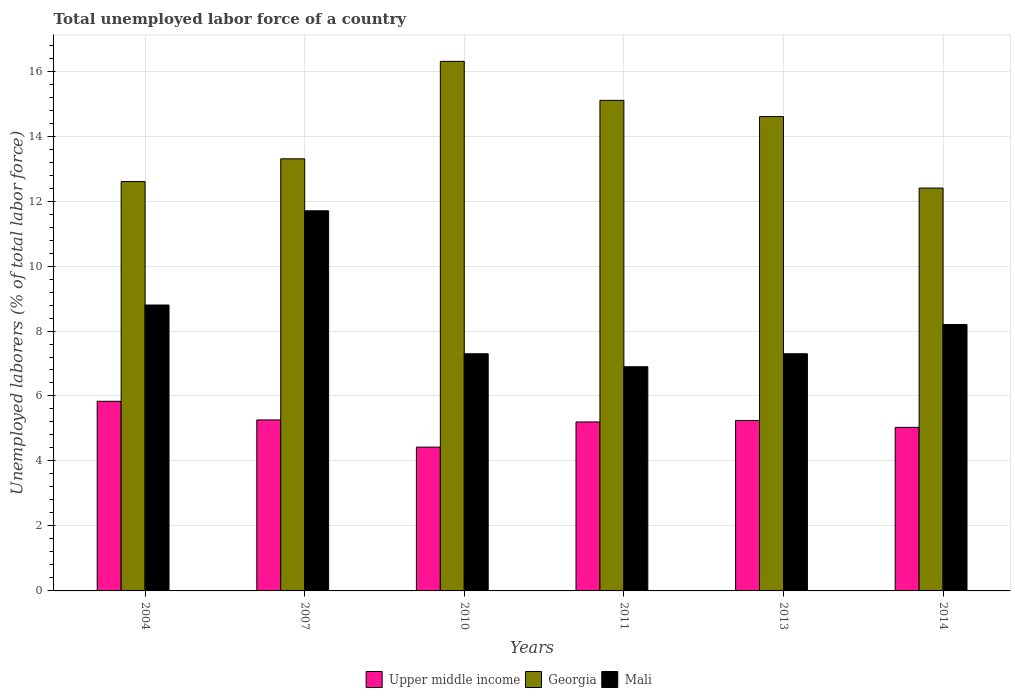Are the number of bars per tick equal to the number of legend labels?
Provide a short and direct response. Yes. How many bars are there on the 4th tick from the left?
Give a very brief answer. 3. What is the label of the 3rd group of bars from the left?
Your response must be concise. 2010. In how many cases, is the number of bars for a given year not equal to the number of legend labels?
Your answer should be compact. 0. What is the total unemployed labor force in Georgia in 2010?
Keep it short and to the point. 16.3. Across all years, what is the maximum total unemployed labor force in Upper middle income?
Your response must be concise. 5.84. Across all years, what is the minimum total unemployed labor force in Mali?
Provide a succinct answer. 6.9. What is the total total unemployed labor force in Upper middle income in the graph?
Your response must be concise. 31.01. What is the difference between the total unemployed labor force in Mali in 2007 and that in 2011?
Keep it short and to the point. 4.8. What is the difference between the total unemployed labor force in Mali in 2011 and the total unemployed labor force in Georgia in 2014?
Give a very brief answer. -5.5. What is the average total unemployed labor force in Georgia per year?
Offer a terse response. 14.05. In the year 2013, what is the difference between the total unemployed labor force in Upper middle income and total unemployed labor force in Mali?
Ensure brevity in your answer.  -2.05. In how many years, is the total unemployed labor force in Mali greater than 8 %?
Keep it short and to the point. 3. What is the ratio of the total unemployed labor force in Georgia in 2004 to that in 2011?
Make the answer very short. 0.83. Is the total unemployed labor force in Georgia in 2007 less than that in 2013?
Offer a terse response. Yes. What is the difference between the highest and the second highest total unemployed labor force in Upper middle income?
Your response must be concise. 0.57. What is the difference between the highest and the lowest total unemployed labor force in Mali?
Make the answer very short. 4.8. In how many years, is the total unemployed labor force in Georgia greater than the average total unemployed labor force in Georgia taken over all years?
Provide a succinct answer. 3. Is the sum of the total unemployed labor force in Upper middle income in 2004 and 2007 greater than the maximum total unemployed labor force in Mali across all years?
Your answer should be very brief. No. What does the 3rd bar from the left in 2004 represents?
Provide a succinct answer. Mali. What does the 3rd bar from the right in 2007 represents?
Offer a terse response. Upper middle income. Are all the bars in the graph horizontal?
Offer a very short reply. No. How many years are there in the graph?
Your response must be concise. 6. What is the difference between two consecutive major ticks on the Y-axis?
Offer a very short reply. 2. Where does the legend appear in the graph?
Ensure brevity in your answer.  Bottom center. How many legend labels are there?
Ensure brevity in your answer.  3. What is the title of the graph?
Provide a succinct answer. Total unemployed labor force of a country. What is the label or title of the X-axis?
Provide a short and direct response. Years. What is the label or title of the Y-axis?
Make the answer very short. Unemployed laborers (% of total labor force). What is the Unemployed laborers (% of total labor force) in Upper middle income in 2004?
Offer a very short reply. 5.84. What is the Unemployed laborers (% of total labor force) of Georgia in 2004?
Provide a short and direct response. 12.6. What is the Unemployed laborers (% of total labor force) of Mali in 2004?
Offer a terse response. 8.8. What is the Unemployed laborers (% of total labor force) of Upper middle income in 2007?
Make the answer very short. 5.26. What is the Unemployed laborers (% of total labor force) in Georgia in 2007?
Your answer should be compact. 13.3. What is the Unemployed laborers (% of total labor force) in Mali in 2007?
Ensure brevity in your answer.  11.7. What is the Unemployed laborers (% of total labor force) in Upper middle income in 2010?
Provide a short and direct response. 4.43. What is the Unemployed laborers (% of total labor force) of Georgia in 2010?
Your answer should be very brief. 16.3. What is the Unemployed laborers (% of total labor force) of Mali in 2010?
Your answer should be compact. 7.3. What is the Unemployed laborers (% of total labor force) in Upper middle income in 2011?
Your response must be concise. 5.2. What is the Unemployed laborers (% of total labor force) of Georgia in 2011?
Your answer should be compact. 15.1. What is the Unemployed laborers (% of total labor force) of Mali in 2011?
Give a very brief answer. 6.9. What is the Unemployed laborers (% of total labor force) in Upper middle income in 2013?
Give a very brief answer. 5.25. What is the Unemployed laborers (% of total labor force) of Georgia in 2013?
Provide a short and direct response. 14.6. What is the Unemployed laborers (% of total labor force) in Mali in 2013?
Your response must be concise. 7.3. What is the Unemployed laborers (% of total labor force) of Upper middle income in 2014?
Your response must be concise. 5.03. What is the Unemployed laborers (% of total labor force) in Georgia in 2014?
Give a very brief answer. 12.4. What is the Unemployed laborers (% of total labor force) in Mali in 2014?
Ensure brevity in your answer.  8.2. Across all years, what is the maximum Unemployed laborers (% of total labor force) in Upper middle income?
Offer a very short reply. 5.84. Across all years, what is the maximum Unemployed laborers (% of total labor force) of Georgia?
Provide a short and direct response. 16.3. Across all years, what is the maximum Unemployed laborers (% of total labor force) of Mali?
Keep it short and to the point. 11.7. Across all years, what is the minimum Unemployed laborers (% of total labor force) of Upper middle income?
Provide a succinct answer. 4.43. Across all years, what is the minimum Unemployed laborers (% of total labor force) in Georgia?
Offer a very short reply. 12.4. Across all years, what is the minimum Unemployed laborers (% of total labor force) in Mali?
Keep it short and to the point. 6.9. What is the total Unemployed laborers (% of total labor force) in Upper middle income in the graph?
Ensure brevity in your answer.  31.01. What is the total Unemployed laborers (% of total labor force) of Georgia in the graph?
Your answer should be compact. 84.3. What is the total Unemployed laborers (% of total labor force) of Mali in the graph?
Your answer should be compact. 50.2. What is the difference between the Unemployed laborers (% of total labor force) of Upper middle income in 2004 and that in 2007?
Offer a very short reply. 0.57. What is the difference between the Unemployed laborers (% of total labor force) in Georgia in 2004 and that in 2007?
Provide a succinct answer. -0.7. What is the difference between the Unemployed laborers (% of total labor force) of Mali in 2004 and that in 2007?
Offer a very short reply. -2.9. What is the difference between the Unemployed laborers (% of total labor force) of Upper middle income in 2004 and that in 2010?
Give a very brief answer. 1.41. What is the difference between the Unemployed laborers (% of total labor force) of Georgia in 2004 and that in 2010?
Your response must be concise. -3.7. What is the difference between the Unemployed laborers (% of total labor force) of Mali in 2004 and that in 2010?
Offer a terse response. 1.5. What is the difference between the Unemployed laborers (% of total labor force) of Upper middle income in 2004 and that in 2011?
Your response must be concise. 0.64. What is the difference between the Unemployed laborers (% of total labor force) of Upper middle income in 2004 and that in 2013?
Keep it short and to the point. 0.59. What is the difference between the Unemployed laborers (% of total labor force) of Georgia in 2004 and that in 2013?
Ensure brevity in your answer.  -2. What is the difference between the Unemployed laborers (% of total labor force) in Mali in 2004 and that in 2013?
Your response must be concise. 1.5. What is the difference between the Unemployed laborers (% of total labor force) of Upper middle income in 2004 and that in 2014?
Provide a short and direct response. 0.8. What is the difference between the Unemployed laborers (% of total labor force) of Mali in 2004 and that in 2014?
Your answer should be very brief. 0.6. What is the difference between the Unemployed laborers (% of total labor force) in Upper middle income in 2007 and that in 2010?
Ensure brevity in your answer.  0.84. What is the difference between the Unemployed laborers (% of total labor force) in Mali in 2007 and that in 2010?
Give a very brief answer. 4.4. What is the difference between the Unemployed laborers (% of total labor force) in Upper middle income in 2007 and that in 2011?
Your answer should be compact. 0.06. What is the difference between the Unemployed laborers (% of total labor force) in Georgia in 2007 and that in 2011?
Your response must be concise. -1.8. What is the difference between the Unemployed laborers (% of total labor force) of Upper middle income in 2007 and that in 2013?
Provide a succinct answer. 0.02. What is the difference between the Unemployed laborers (% of total labor force) in Upper middle income in 2007 and that in 2014?
Make the answer very short. 0.23. What is the difference between the Unemployed laborers (% of total labor force) in Mali in 2007 and that in 2014?
Ensure brevity in your answer.  3.5. What is the difference between the Unemployed laborers (% of total labor force) of Upper middle income in 2010 and that in 2011?
Your response must be concise. -0.77. What is the difference between the Unemployed laborers (% of total labor force) of Georgia in 2010 and that in 2011?
Offer a very short reply. 1.2. What is the difference between the Unemployed laborers (% of total labor force) of Mali in 2010 and that in 2011?
Give a very brief answer. 0.4. What is the difference between the Unemployed laborers (% of total labor force) of Upper middle income in 2010 and that in 2013?
Ensure brevity in your answer.  -0.82. What is the difference between the Unemployed laborers (% of total labor force) of Georgia in 2010 and that in 2013?
Offer a very short reply. 1.7. What is the difference between the Unemployed laborers (% of total labor force) of Mali in 2010 and that in 2013?
Give a very brief answer. 0. What is the difference between the Unemployed laborers (% of total labor force) of Upper middle income in 2010 and that in 2014?
Offer a terse response. -0.61. What is the difference between the Unemployed laborers (% of total labor force) of Upper middle income in 2011 and that in 2013?
Offer a terse response. -0.05. What is the difference between the Unemployed laborers (% of total labor force) of Georgia in 2011 and that in 2013?
Your answer should be compact. 0.5. What is the difference between the Unemployed laborers (% of total labor force) in Upper middle income in 2011 and that in 2014?
Your response must be concise. 0.17. What is the difference between the Unemployed laborers (% of total labor force) in Georgia in 2011 and that in 2014?
Give a very brief answer. 2.7. What is the difference between the Unemployed laborers (% of total labor force) of Mali in 2011 and that in 2014?
Provide a short and direct response. -1.3. What is the difference between the Unemployed laborers (% of total labor force) of Upper middle income in 2013 and that in 2014?
Provide a short and direct response. 0.21. What is the difference between the Unemployed laborers (% of total labor force) in Upper middle income in 2004 and the Unemployed laborers (% of total labor force) in Georgia in 2007?
Make the answer very short. -7.46. What is the difference between the Unemployed laborers (% of total labor force) of Upper middle income in 2004 and the Unemployed laborers (% of total labor force) of Mali in 2007?
Keep it short and to the point. -5.86. What is the difference between the Unemployed laborers (% of total labor force) in Upper middle income in 2004 and the Unemployed laborers (% of total labor force) in Georgia in 2010?
Provide a short and direct response. -10.46. What is the difference between the Unemployed laborers (% of total labor force) of Upper middle income in 2004 and the Unemployed laborers (% of total labor force) of Mali in 2010?
Ensure brevity in your answer.  -1.46. What is the difference between the Unemployed laborers (% of total labor force) of Georgia in 2004 and the Unemployed laborers (% of total labor force) of Mali in 2010?
Provide a succinct answer. 5.3. What is the difference between the Unemployed laborers (% of total labor force) in Upper middle income in 2004 and the Unemployed laborers (% of total labor force) in Georgia in 2011?
Your response must be concise. -9.26. What is the difference between the Unemployed laborers (% of total labor force) in Upper middle income in 2004 and the Unemployed laborers (% of total labor force) in Mali in 2011?
Your answer should be compact. -1.06. What is the difference between the Unemployed laborers (% of total labor force) in Upper middle income in 2004 and the Unemployed laborers (% of total labor force) in Georgia in 2013?
Offer a very short reply. -8.76. What is the difference between the Unemployed laborers (% of total labor force) in Upper middle income in 2004 and the Unemployed laborers (% of total labor force) in Mali in 2013?
Give a very brief answer. -1.46. What is the difference between the Unemployed laborers (% of total labor force) in Upper middle income in 2004 and the Unemployed laborers (% of total labor force) in Georgia in 2014?
Your response must be concise. -6.56. What is the difference between the Unemployed laborers (% of total labor force) in Upper middle income in 2004 and the Unemployed laborers (% of total labor force) in Mali in 2014?
Offer a very short reply. -2.36. What is the difference between the Unemployed laborers (% of total labor force) in Upper middle income in 2007 and the Unemployed laborers (% of total labor force) in Georgia in 2010?
Your response must be concise. -11.04. What is the difference between the Unemployed laborers (% of total labor force) in Upper middle income in 2007 and the Unemployed laborers (% of total labor force) in Mali in 2010?
Your answer should be compact. -2.04. What is the difference between the Unemployed laborers (% of total labor force) of Georgia in 2007 and the Unemployed laborers (% of total labor force) of Mali in 2010?
Provide a succinct answer. 6. What is the difference between the Unemployed laborers (% of total labor force) in Upper middle income in 2007 and the Unemployed laborers (% of total labor force) in Georgia in 2011?
Make the answer very short. -9.84. What is the difference between the Unemployed laborers (% of total labor force) in Upper middle income in 2007 and the Unemployed laborers (% of total labor force) in Mali in 2011?
Your answer should be very brief. -1.64. What is the difference between the Unemployed laborers (% of total labor force) in Upper middle income in 2007 and the Unemployed laborers (% of total labor force) in Georgia in 2013?
Make the answer very short. -9.34. What is the difference between the Unemployed laborers (% of total labor force) in Upper middle income in 2007 and the Unemployed laborers (% of total labor force) in Mali in 2013?
Your response must be concise. -2.04. What is the difference between the Unemployed laborers (% of total labor force) of Georgia in 2007 and the Unemployed laborers (% of total labor force) of Mali in 2013?
Provide a short and direct response. 6. What is the difference between the Unemployed laborers (% of total labor force) of Upper middle income in 2007 and the Unemployed laborers (% of total labor force) of Georgia in 2014?
Your response must be concise. -7.14. What is the difference between the Unemployed laborers (% of total labor force) of Upper middle income in 2007 and the Unemployed laborers (% of total labor force) of Mali in 2014?
Give a very brief answer. -2.94. What is the difference between the Unemployed laborers (% of total labor force) in Upper middle income in 2010 and the Unemployed laborers (% of total labor force) in Georgia in 2011?
Keep it short and to the point. -10.67. What is the difference between the Unemployed laborers (% of total labor force) of Upper middle income in 2010 and the Unemployed laborers (% of total labor force) of Mali in 2011?
Give a very brief answer. -2.47. What is the difference between the Unemployed laborers (% of total labor force) of Georgia in 2010 and the Unemployed laborers (% of total labor force) of Mali in 2011?
Offer a terse response. 9.4. What is the difference between the Unemployed laborers (% of total labor force) of Upper middle income in 2010 and the Unemployed laborers (% of total labor force) of Georgia in 2013?
Make the answer very short. -10.17. What is the difference between the Unemployed laborers (% of total labor force) of Upper middle income in 2010 and the Unemployed laborers (% of total labor force) of Mali in 2013?
Give a very brief answer. -2.87. What is the difference between the Unemployed laborers (% of total labor force) in Upper middle income in 2010 and the Unemployed laborers (% of total labor force) in Georgia in 2014?
Your answer should be compact. -7.97. What is the difference between the Unemployed laborers (% of total labor force) of Upper middle income in 2010 and the Unemployed laborers (% of total labor force) of Mali in 2014?
Provide a short and direct response. -3.77. What is the difference between the Unemployed laborers (% of total labor force) of Georgia in 2010 and the Unemployed laborers (% of total labor force) of Mali in 2014?
Provide a succinct answer. 8.1. What is the difference between the Unemployed laborers (% of total labor force) of Upper middle income in 2011 and the Unemployed laborers (% of total labor force) of Georgia in 2013?
Provide a short and direct response. -9.4. What is the difference between the Unemployed laborers (% of total labor force) of Upper middle income in 2011 and the Unemployed laborers (% of total labor force) of Mali in 2013?
Keep it short and to the point. -2.1. What is the difference between the Unemployed laborers (% of total labor force) of Upper middle income in 2011 and the Unemployed laborers (% of total labor force) of Georgia in 2014?
Your response must be concise. -7.2. What is the difference between the Unemployed laborers (% of total labor force) in Upper middle income in 2011 and the Unemployed laborers (% of total labor force) in Mali in 2014?
Make the answer very short. -3. What is the difference between the Unemployed laborers (% of total labor force) in Upper middle income in 2013 and the Unemployed laborers (% of total labor force) in Georgia in 2014?
Ensure brevity in your answer.  -7.15. What is the difference between the Unemployed laborers (% of total labor force) of Upper middle income in 2013 and the Unemployed laborers (% of total labor force) of Mali in 2014?
Your answer should be compact. -2.95. What is the average Unemployed laborers (% of total labor force) of Upper middle income per year?
Make the answer very short. 5.17. What is the average Unemployed laborers (% of total labor force) in Georgia per year?
Your answer should be compact. 14.05. What is the average Unemployed laborers (% of total labor force) in Mali per year?
Your answer should be very brief. 8.37. In the year 2004, what is the difference between the Unemployed laborers (% of total labor force) of Upper middle income and Unemployed laborers (% of total labor force) of Georgia?
Offer a terse response. -6.76. In the year 2004, what is the difference between the Unemployed laborers (% of total labor force) of Upper middle income and Unemployed laborers (% of total labor force) of Mali?
Offer a terse response. -2.96. In the year 2007, what is the difference between the Unemployed laborers (% of total labor force) of Upper middle income and Unemployed laborers (% of total labor force) of Georgia?
Your answer should be compact. -8.04. In the year 2007, what is the difference between the Unemployed laborers (% of total labor force) in Upper middle income and Unemployed laborers (% of total labor force) in Mali?
Keep it short and to the point. -6.44. In the year 2010, what is the difference between the Unemployed laborers (% of total labor force) of Upper middle income and Unemployed laborers (% of total labor force) of Georgia?
Make the answer very short. -11.87. In the year 2010, what is the difference between the Unemployed laborers (% of total labor force) in Upper middle income and Unemployed laborers (% of total labor force) in Mali?
Your answer should be compact. -2.87. In the year 2010, what is the difference between the Unemployed laborers (% of total labor force) of Georgia and Unemployed laborers (% of total labor force) of Mali?
Offer a very short reply. 9. In the year 2011, what is the difference between the Unemployed laborers (% of total labor force) of Upper middle income and Unemployed laborers (% of total labor force) of Georgia?
Your answer should be very brief. -9.9. In the year 2011, what is the difference between the Unemployed laborers (% of total labor force) of Upper middle income and Unemployed laborers (% of total labor force) of Mali?
Offer a terse response. -1.7. In the year 2013, what is the difference between the Unemployed laborers (% of total labor force) of Upper middle income and Unemployed laborers (% of total labor force) of Georgia?
Offer a very short reply. -9.35. In the year 2013, what is the difference between the Unemployed laborers (% of total labor force) in Upper middle income and Unemployed laborers (% of total labor force) in Mali?
Ensure brevity in your answer.  -2.05. In the year 2014, what is the difference between the Unemployed laborers (% of total labor force) in Upper middle income and Unemployed laborers (% of total labor force) in Georgia?
Keep it short and to the point. -7.37. In the year 2014, what is the difference between the Unemployed laborers (% of total labor force) of Upper middle income and Unemployed laborers (% of total labor force) of Mali?
Keep it short and to the point. -3.17. What is the ratio of the Unemployed laborers (% of total labor force) of Upper middle income in 2004 to that in 2007?
Offer a very short reply. 1.11. What is the ratio of the Unemployed laborers (% of total labor force) in Georgia in 2004 to that in 2007?
Your answer should be very brief. 0.95. What is the ratio of the Unemployed laborers (% of total labor force) of Mali in 2004 to that in 2007?
Offer a very short reply. 0.75. What is the ratio of the Unemployed laborers (% of total labor force) in Upper middle income in 2004 to that in 2010?
Your answer should be very brief. 1.32. What is the ratio of the Unemployed laborers (% of total labor force) of Georgia in 2004 to that in 2010?
Offer a very short reply. 0.77. What is the ratio of the Unemployed laborers (% of total labor force) of Mali in 2004 to that in 2010?
Offer a terse response. 1.21. What is the ratio of the Unemployed laborers (% of total labor force) of Upper middle income in 2004 to that in 2011?
Provide a succinct answer. 1.12. What is the ratio of the Unemployed laborers (% of total labor force) in Georgia in 2004 to that in 2011?
Keep it short and to the point. 0.83. What is the ratio of the Unemployed laborers (% of total labor force) in Mali in 2004 to that in 2011?
Keep it short and to the point. 1.28. What is the ratio of the Unemployed laborers (% of total labor force) in Upper middle income in 2004 to that in 2013?
Keep it short and to the point. 1.11. What is the ratio of the Unemployed laborers (% of total labor force) in Georgia in 2004 to that in 2013?
Your answer should be very brief. 0.86. What is the ratio of the Unemployed laborers (% of total labor force) in Mali in 2004 to that in 2013?
Keep it short and to the point. 1.21. What is the ratio of the Unemployed laborers (% of total labor force) of Upper middle income in 2004 to that in 2014?
Offer a terse response. 1.16. What is the ratio of the Unemployed laborers (% of total labor force) in Georgia in 2004 to that in 2014?
Your response must be concise. 1.02. What is the ratio of the Unemployed laborers (% of total labor force) in Mali in 2004 to that in 2014?
Your answer should be very brief. 1.07. What is the ratio of the Unemployed laborers (% of total labor force) of Upper middle income in 2007 to that in 2010?
Offer a very short reply. 1.19. What is the ratio of the Unemployed laborers (% of total labor force) of Georgia in 2007 to that in 2010?
Give a very brief answer. 0.82. What is the ratio of the Unemployed laborers (% of total labor force) of Mali in 2007 to that in 2010?
Your answer should be compact. 1.6. What is the ratio of the Unemployed laborers (% of total labor force) in Upper middle income in 2007 to that in 2011?
Your answer should be compact. 1.01. What is the ratio of the Unemployed laborers (% of total labor force) of Georgia in 2007 to that in 2011?
Your answer should be compact. 0.88. What is the ratio of the Unemployed laborers (% of total labor force) in Mali in 2007 to that in 2011?
Ensure brevity in your answer.  1.7. What is the ratio of the Unemployed laborers (% of total labor force) of Georgia in 2007 to that in 2013?
Your answer should be very brief. 0.91. What is the ratio of the Unemployed laborers (% of total labor force) in Mali in 2007 to that in 2013?
Give a very brief answer. 1.6. What is the ratio of the Unemployed laborers (% of total labor force) in Upper middle income in 2007 to that in 2014?
Give a very brief answer. 1.05. What is the ratio of the Unemployed laborers (% of total labor force) of Georgia in 2007 to that in 2014?
Your answer should be compact. 1.07. What is the ratio of the Unemployed laborers (% of total labor force) of Mali in 2007 to that in 2014?
Your response must be concise. 1.43. What is the ratio of the Unemployed laborers (% of total labor force) in Upper middle income in 2010 to that in 2011?
Your response must be concise. 0.85. What is the ratio of the Unemployed laborers (% of total labor force) of Georgia in 2010 to that in 2011?
Keep it short and to the point. 1.08. What is the ratio of the Unemployed laborers (% of total labor force) of Mali in 2010 to that in 2011?
Provide a short and direct response. 1.06. What is the ratio of the Unemployed laborers (% of total labor force) of Upper middle income in 2010 to that in 2013?
Provide a short and direct response. 0.84. What is the ratio of the Unemployed laborers (% of total labor force) in Georgia in 2010 to that in 2013?
Offer a terse response. 1.12. What is the ratio of the Unemployed laborers (% of total labor force) in Upper middle income in 2010 to that in 2014?
Provide a short and direct response. 0.88. What is the ratio of the Unemployed laborers (% of total labor force) in Georgia in 2010 to that in 2014?
Your answer should be very brief. 1.31. What is the ratio of the Unemployed laborers (% of total labor force) in Mali in 2010 to that in 2014?
Your response must be concise. 0.89. What is the ratio of the Unemployed laborers (% of total labor force) in Upper middle income in 2011 to that in 2013?
Your answer should be compact. 0.99. What is the ratio of the Unemployed laborers (% of total labor force) of Georgia in 2011 to that in 2013?
Your answer should be compact. 1.03. What is the ratio of the Unemployed laborers (% of total labor force) of Mali in 2011 to that in 2013?
Make the answer very short. 0.95. What is the ratio of the Unemployed laborers (% of total labor force) in Upper middle income in 2011 to that in 2014?
Ensure brevity in your answer.  1.03. What is the ratio of the Unemployed laborers (% of total labor force) of Georgia in 2011 to that in 2014?
Your answer should be compact. 1.22. What is the ratio of the Unemployed laborers (% of total labor force) of Mali in 2011 to that in 2014?
Your answer should be very brief. 0.84. What is the ratio of the Unemployed laborers (% of total labor force) in Upper middle income in 2013 to that in 2014?
Make the answer very short. 1.04. What is the ratio of the Unemployed laborers (% of total labor force) in Georgia in 2013 to that in 2014?
Ensure brevity in your answer.  1.18. What is the ratio of the Unemployed laborers (% of total labor force) in Mali in 2013 to that in 2014?
Offer a terse response. 0.89. What is the difference between the highest and the second highest Unemployed laborers (% of total labor force) of Upper middle income?
Ensure brevity in your answer.  0.57. What is the difference between the highest and the lowest Unemployed laborers (% of total labor force) of Upper middle income?
Your answer should be very brief. 1.41. What is the difference between the highest and the lowest Unemployed laborers (% of total labor force) in Georgia?
Offer a terse response. 3.9. What is the difference between the highest and the lowest Unemployed laborers (% of total labor force) of Mali?
Provide a short and direct response. 4.8. 